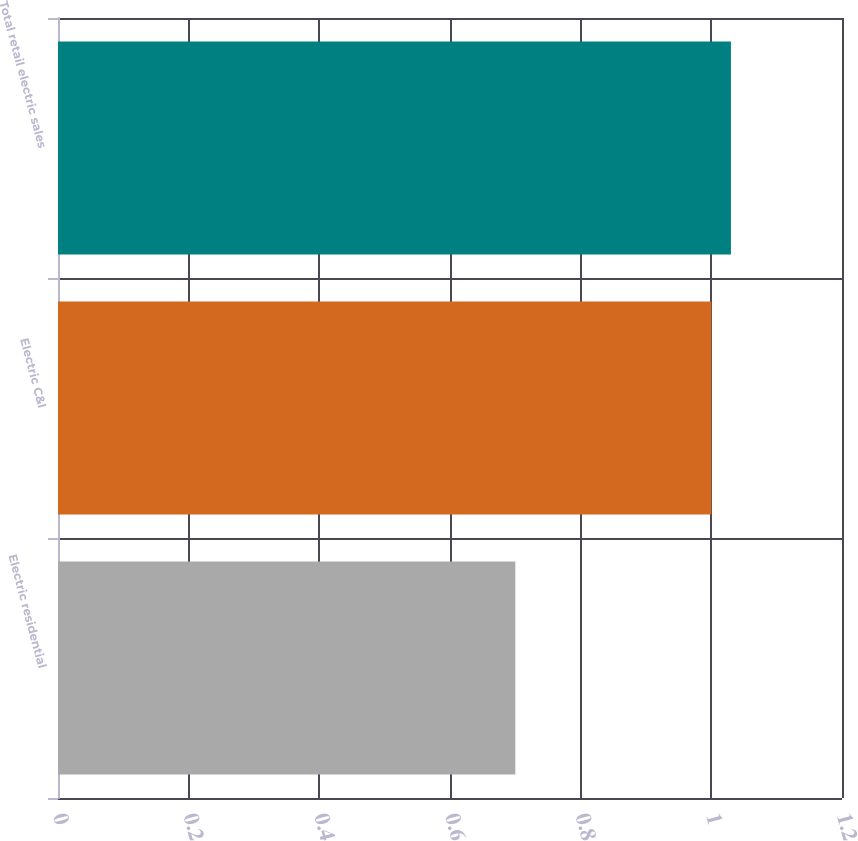Convert chart to OTSL. <chart><loc_0><loc_0><loc_500><loc_500><bar_chart><fcel>Electric residential<fcel>Electric C&I<fcel>Total retail electric sales<nl><fcel>0.7<fcel>1<fcel>1.03<nl></chart> 